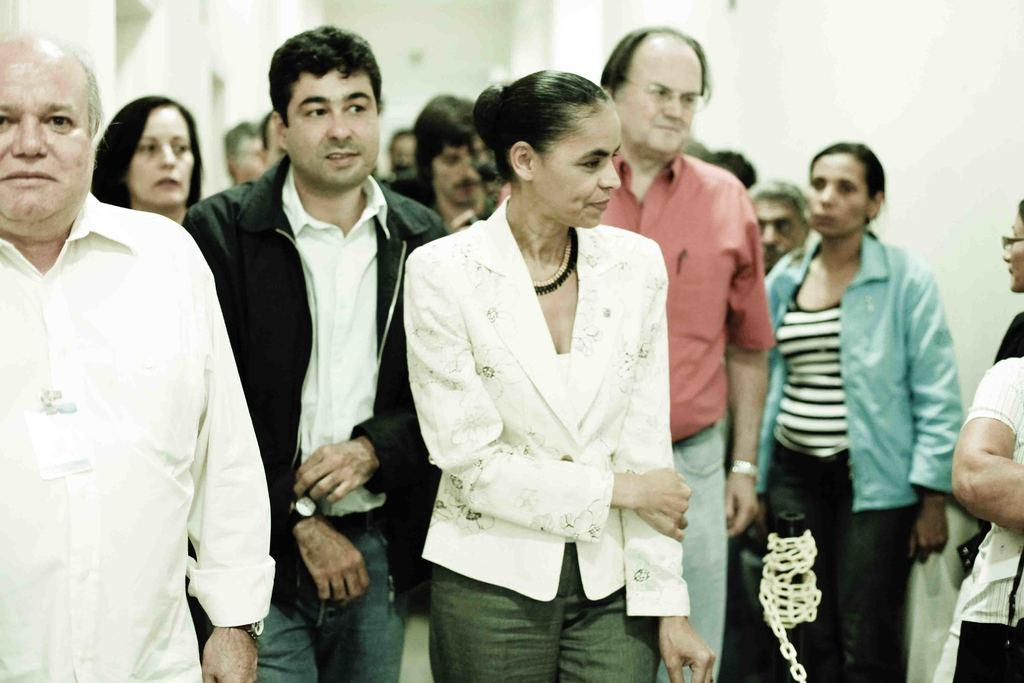How many people are in the image? There is a group of people in the image, but the exact number cannot be determined from the provided facts. What are the people doing in the image? The people are standing on the ground. Can you describe the background of the image? The background of the image is blurred. What type of coal can be seen bursting into flames in the image? There is no coal or flames present in the image; it features a group of people standing on the ground with a blurred background. 